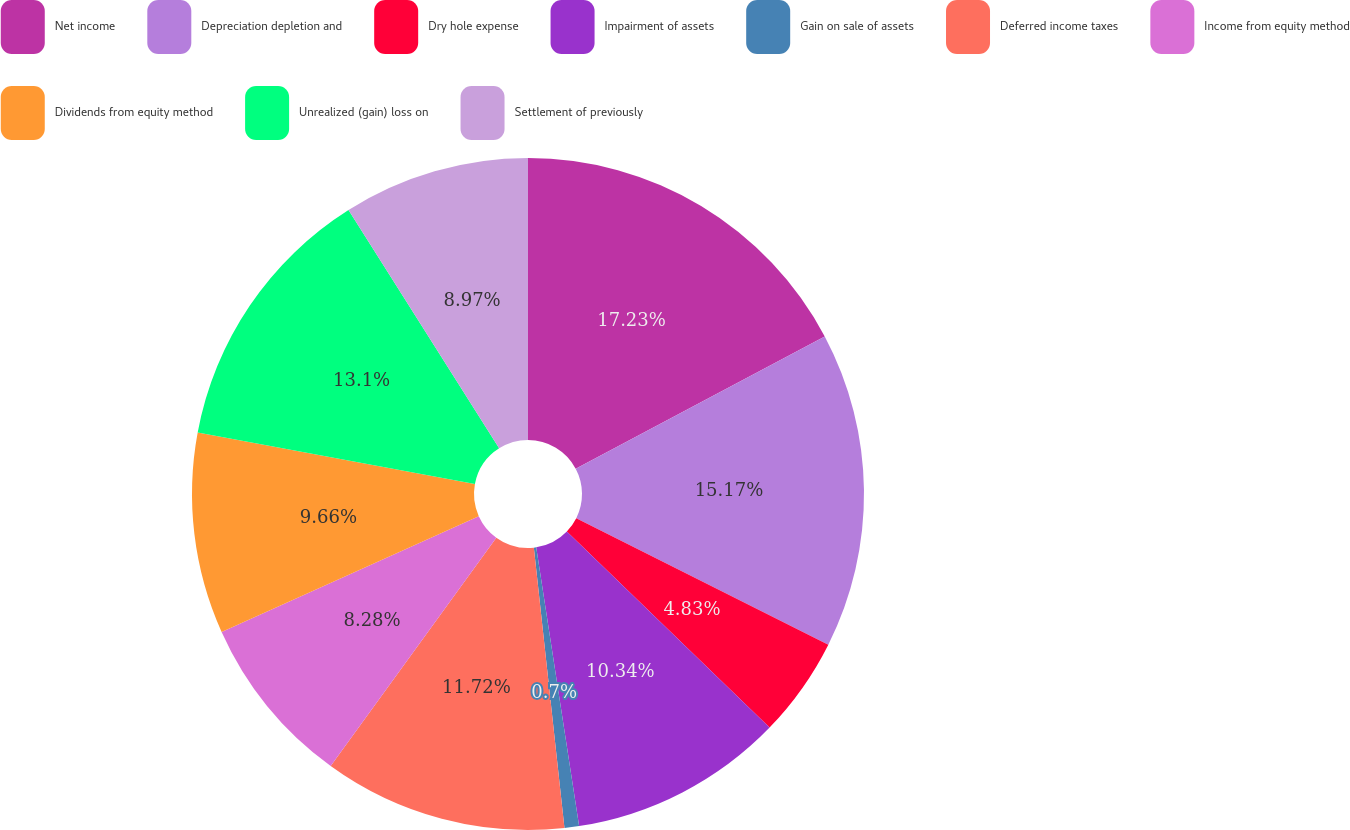Convert chart to OTSL. <chart><loc_0><loc_0><loc_500><loc_500><pie_chart><fcel>Net income<fcel>Depreciation depletion and<fcel>Dry hole expense<fcel>Impairment of assets<fcel>Gain on sale of assets<fcel>Deferred income taxes<fcel>Income from equity method<fcel>Dividends from equity method<fcel>Unrealized (gain) loss on<fcel>Settlement of previously<nl><fcel>17.23%<fcel>15.17%<fcel>4.83%<fcel>10.34%<fcel>0.7%<fcel>11.72%<fcel>8.28%<fcel>9.66%<fcel>13.1%<fcel>8.97%<nl></chart> 